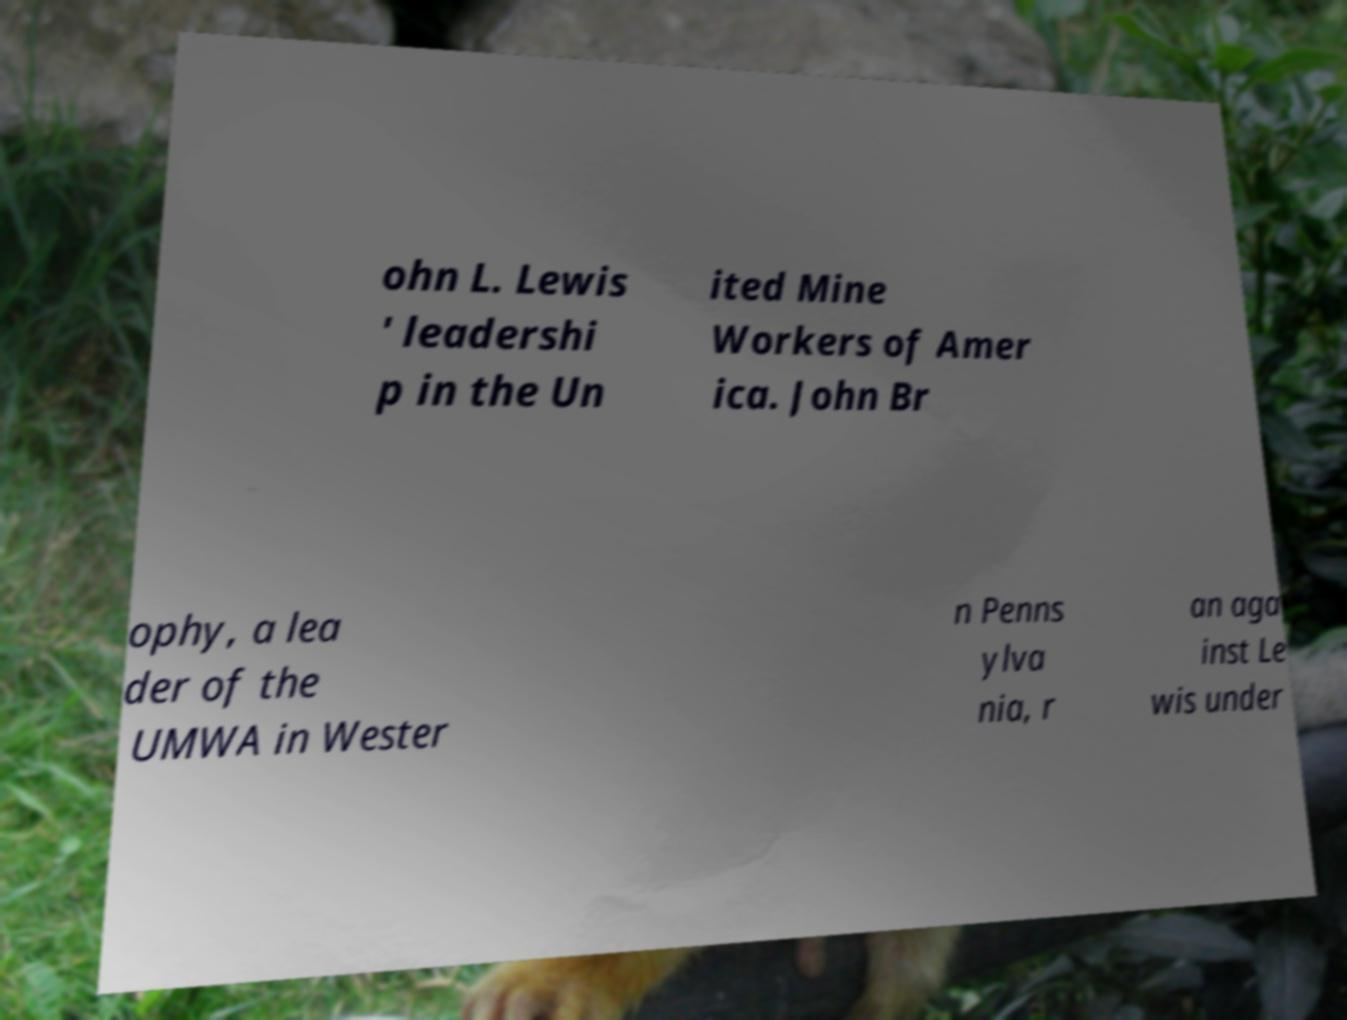I need the written content from this picture converted into text. Can you do that? ohn L. Lewis ' leadershi p in the Un ited Mine Workers of Amer ica. John Br ophy, a lea der of the UMWA in Wester n Penns ylva nia, r an aga inst Le wis under 